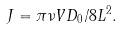<formula> <loc_0><loc_0><loc_500><loc_500>J = \pi \nu V D _ { 0 } / 8 L ^ { 2 } .</formula> 